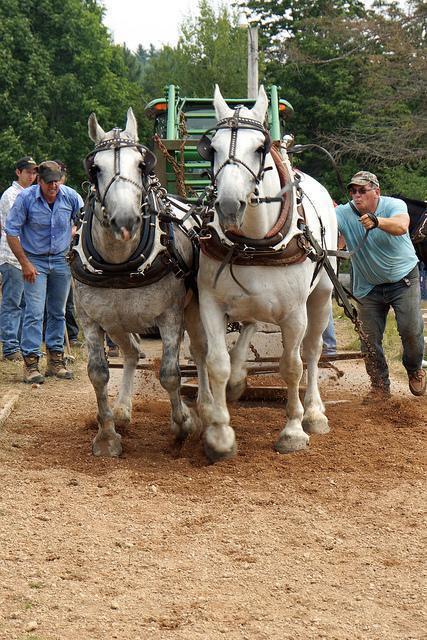What is the man on the right doing?
Select the accurate answer and provide explanation: 'Answer: answer
Rationale: rationale.'
Options: Stealing horses, beating horses, feeding horses, controlling horses. Answer: controlling horses.
Rationale: These are powerful working animals that need to be guided by a human. 